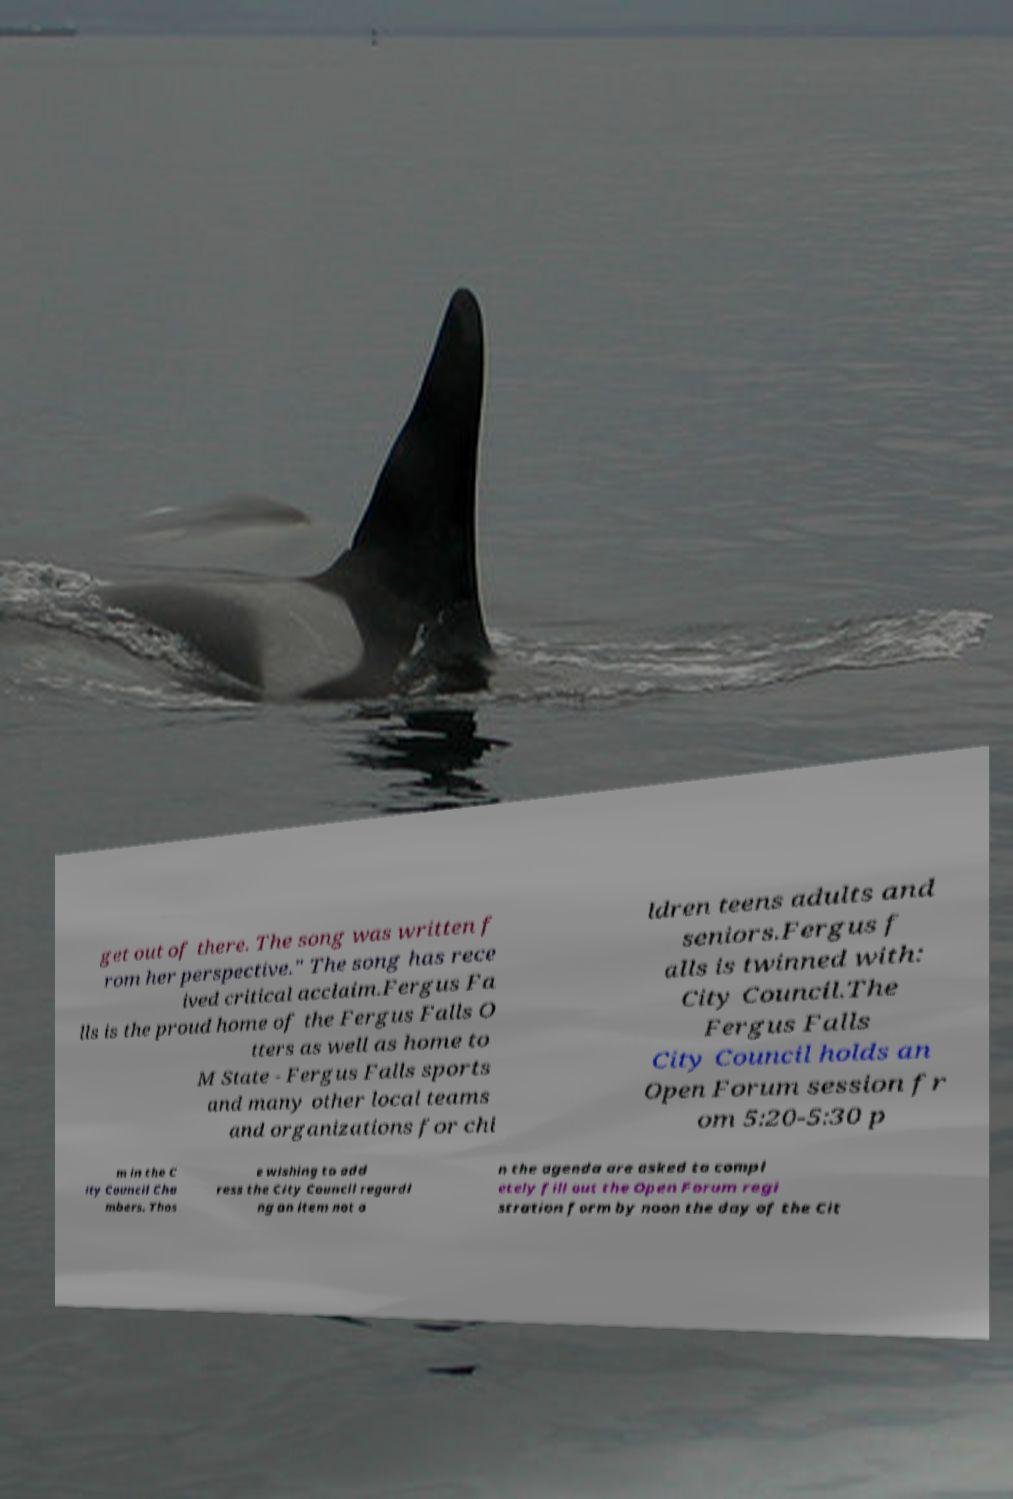For documentation purposes, I need the text within this image transcribed. Could you provide that? get out of there. The song was written f rom her perspective." The song has rece ived critical acclaim.Fergus Fa lls is the proud home of the Fergus Falls O tters as well as home to M State - Fergus Falls sports and many other local teams and organizations for chi ldren teens adults and seniors.Fergus f alls is twinned with: City Council.The Fergus Falls City Council holds an Open Forum session fr om 5:20-5:30 p m in the C ity Council Cha mbers. Thos e wishing to add ress the City Council regardi ng an item not o n the agenda are asked to compl etely fill out the Open Forum regi stration form by noon the day of the Cit 